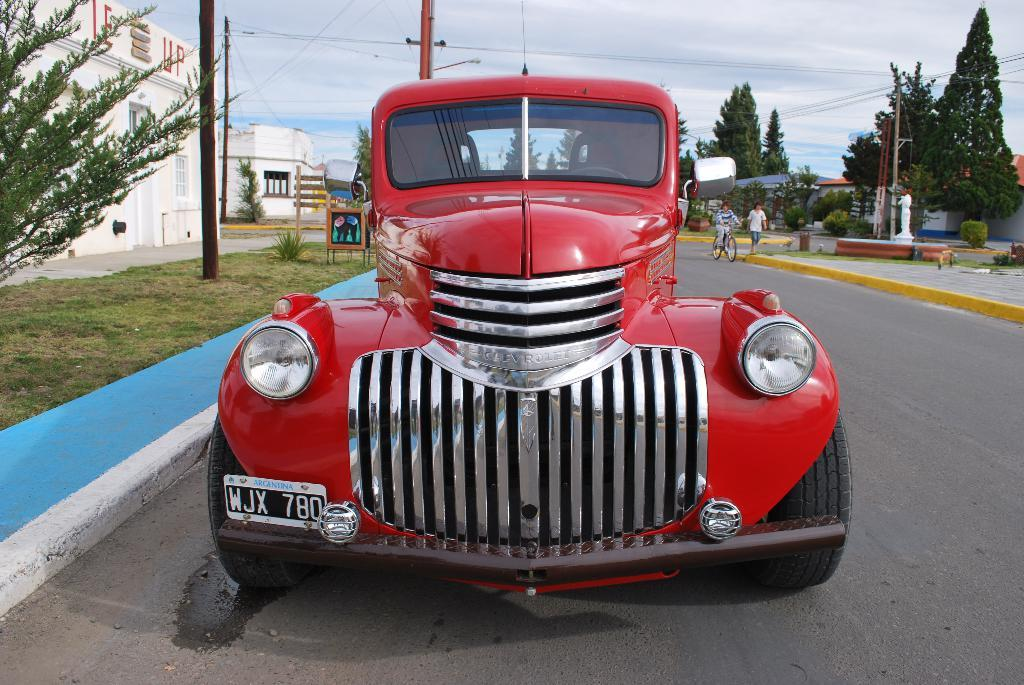What is on the road in the image? There is a vehicle on the road in the image. What can be seen in the background of the image? There are trees, buildings, people, current poles, and plants in the background. What is the condition of the sky in the image? The sky is cloudy in the image. What type of mine can be seen in the image? There is no mine present in the image. Is the vehicle driving through snow in the image? There is no snow present in the image; the sky is cloudy. 